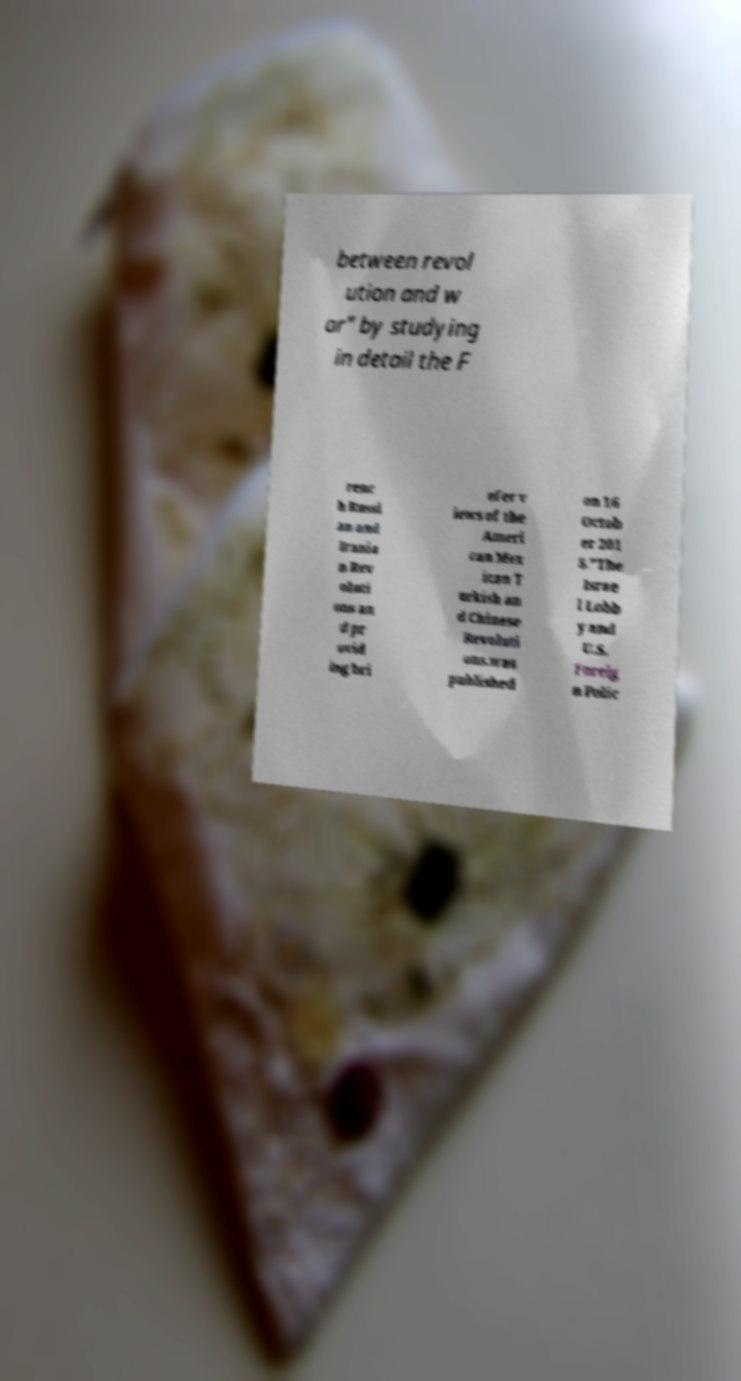Could you assist in decoding the text presented in this image and type it out clearly? between revol ution and w ar" by studying in detail the F renc h Russi an and Irania n Rev oluti ons an d pr ovid ing bri efer v iews of the Ameri can Mex ican T urkish an d Chinese Revoluti ons.was published on 16 Octob er 201 8."The Israe l Lobb y and U.S. Foreig n Polic 